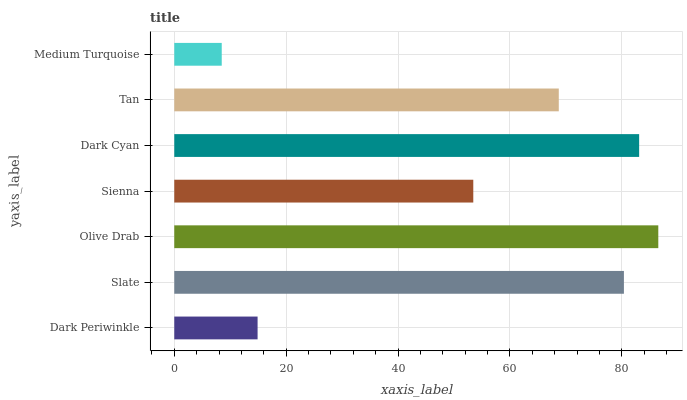Is Medium Turquoise the minimum?
Answer yes or no. Yes. Is Olive Drab the maximum?
Answer yes or no. Yes. Is Slate the minimum?
Answer yes or no. No. Is Slate the maximum?
Answer yes or no. No. Is Slate greater than Dark Periwinkle?
Answer yes or no. Yes. Is Dark Periwinkle less than Slate?
Answer yes or no. Yes. Is Dark Periwinkle greater than Slate?
Answer yes or no. No. Is Slate less than Dark Periwinkle?
Answer yes or no. No. Is Tan the high median?
Answer yes or no. Yes. Is Tan the low median?
Answer yes or no. Yes. Is Medium Turquoise the high median?
Answer yes or no. No. Is Dark Cyan the low median?
Answer yes or no. No. 